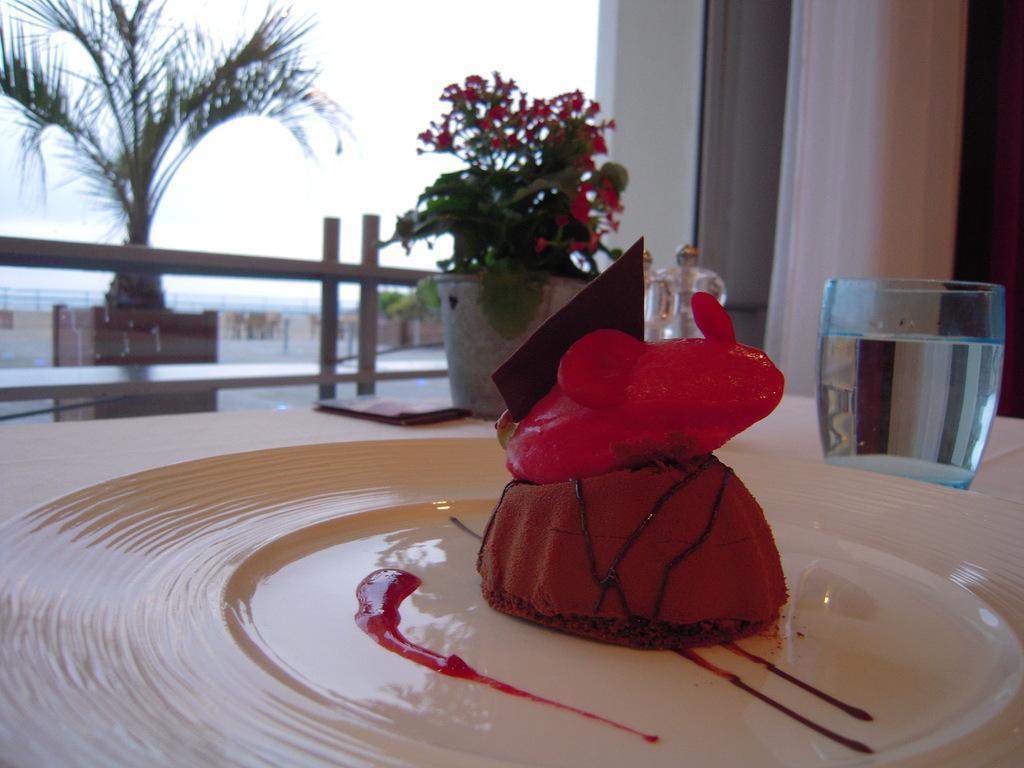Could you give a brief overview of what you see in this image? In this picture there is a plate in the center of the image, in which there is a cake and there is a glass on the right side of the image, there is a flower pot in the center of the image, which are placed on a table, there is a plant on the left side of the image. 